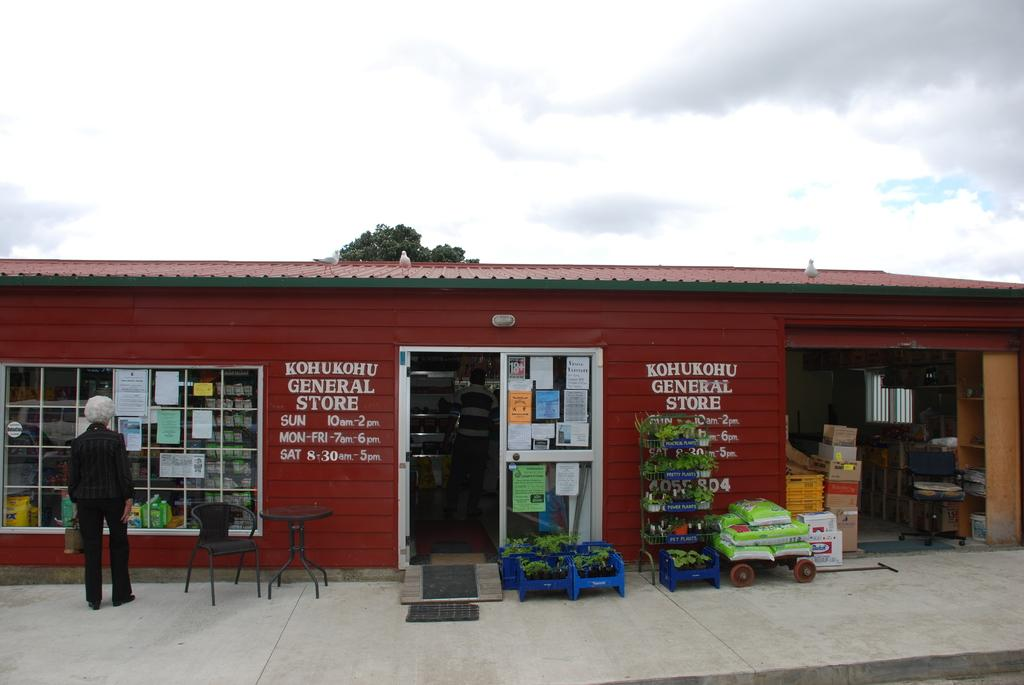<image>
Create a compact narrative representing the image presented. the red general store has the hours painted on the outside of the building 